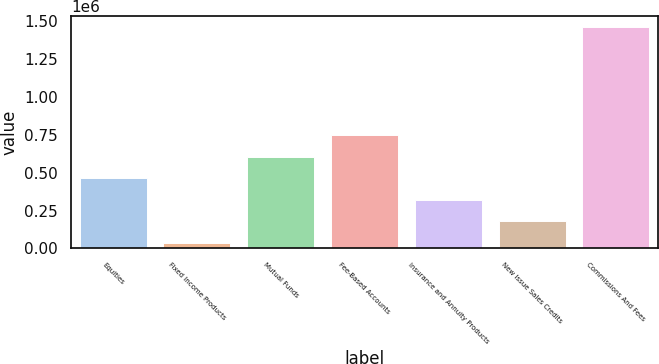Convert chart. <chart><loc_0><loc_0><loc_500><loc_500><bar_chart><fcel>Equities<fcel>Fixed Income Products<fcel>Mutual Funds<fcel>Fee-Based Accounts<fcel>Insurance and Annuity Products<fcel>New Issue Sales Credits<fcel>Commissions And Fees<nl><fcel>464187<fcel>36414<fcel>606778<fcel>749368<fcel>321596<fcel>179005<fcel>1.46232e+06<nl></chart> 